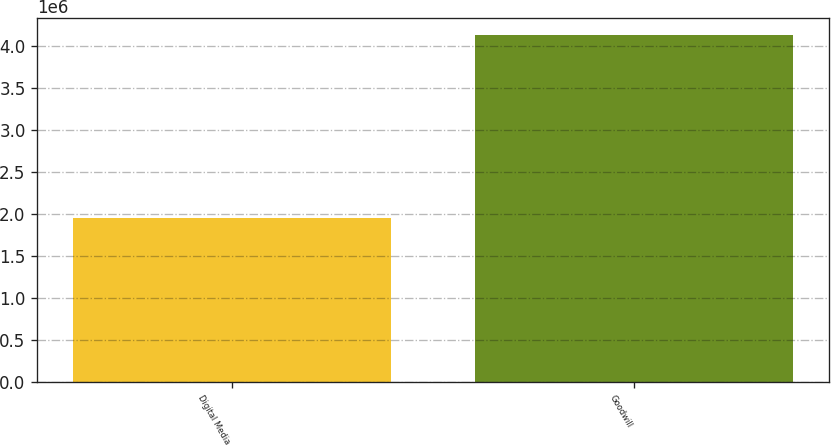Convert chart to OTSL. <chart><loc_0><loc_0><loc_500><loc_500><bar_chart><fcel>Digital Media<fcel>Goodwill<nl><fcel>1.95833e+06<fcel>4.13326e+06<nl></chart> 